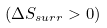Convert formula to latex. <formula><loc_0><loc_0><loc_500><loc_500>( \Delta S _ { s u r r } > 0 )</formula> 